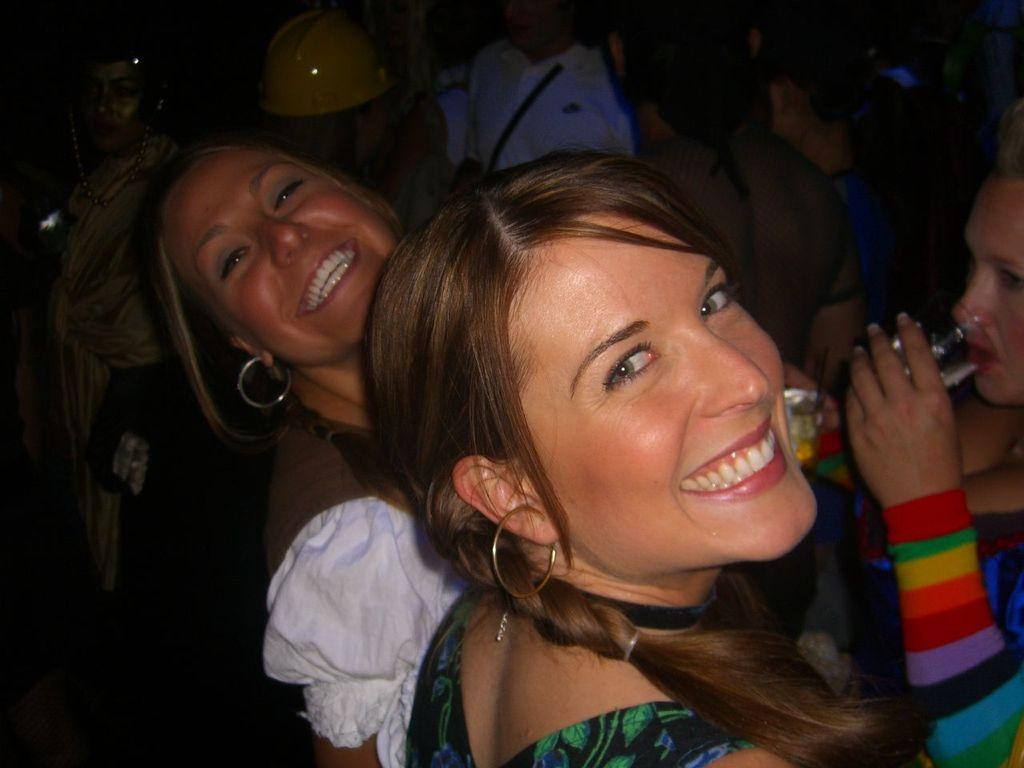How many women are standing and smiling in the middle of the image? There are two women standing and smiling in the middle of the image. What is the woman in front of them doing? In front of them, a woman is standing and drinking. Are there any other people visible in the image? Yes, there are additional people standing near the women. Can you tell me how many basketballs are visible in the image? There are no basketballs present in the image. Is there a giraffe standing near the women in the image? No, there is no giraffe present in the image. 